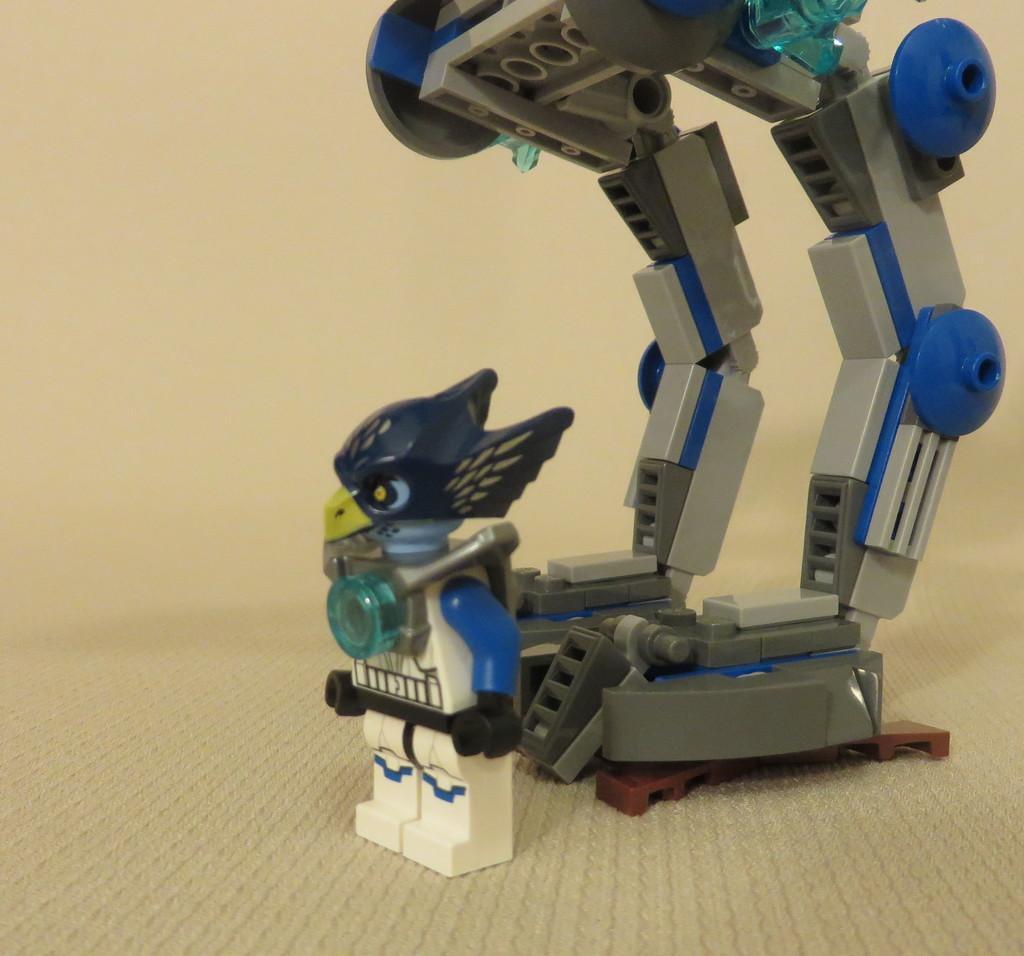In one or two sentences, can you explain what this image depicts? This image consists of a robot made up of plastic is kept on the floor. In the background, there is a wall in cream color. The robot is in blue and grey color. 